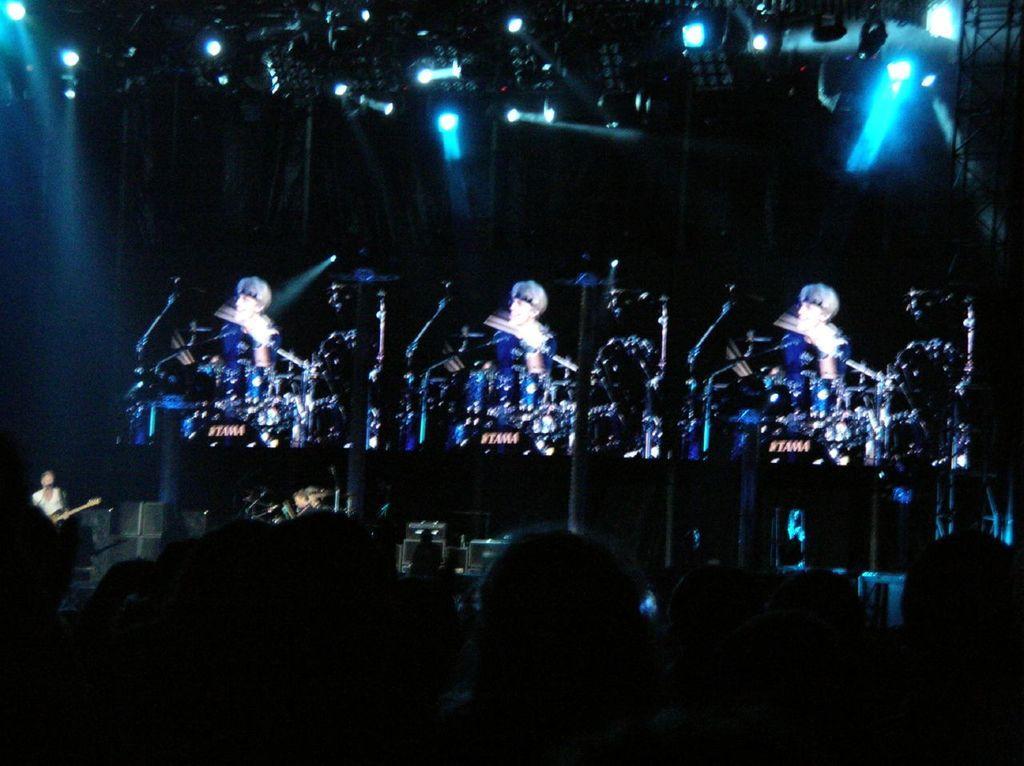In one or two sentences, can you explain what this image depicts? In this picture there are three persons playing musical instruments and there are few lights above them and there are few audience in front of them. 